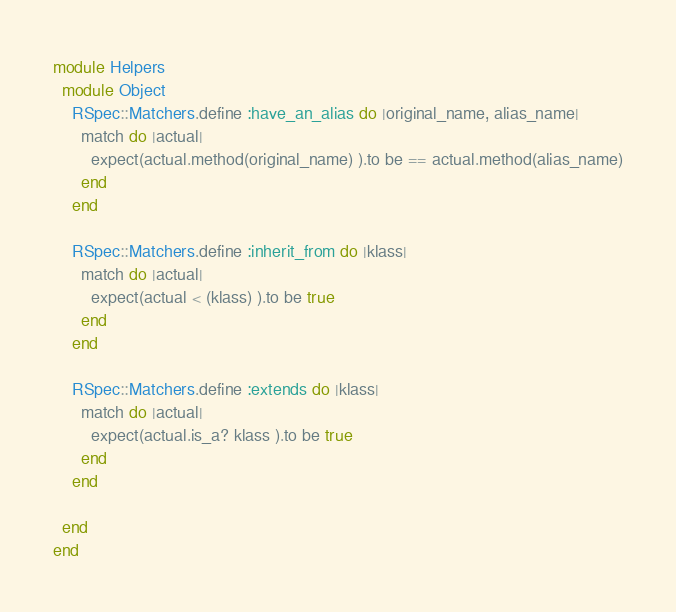Convert code to text. <code><loc_0><loc_0><loc_500><loc_500><_Ruby_>module Helpers
  module Object
    RSpec::Matchers.define :have_an_alias do |original_name, alias_name|
      match do |actual|
        expect(actual.method(original_name) ).to be == actual.method(alias_name)
      end
    end

    RSpec::Matchers.define :inherit_from do |klass|
      match do |actual|
        expect(actual < (klass) ).to be true
      end
    end

    RSpec::Matchers.define :extends do |klass|
      match do |actual|
        expect(actual.is_a? klass ).to be true
      end
    end

  end
end</code> 